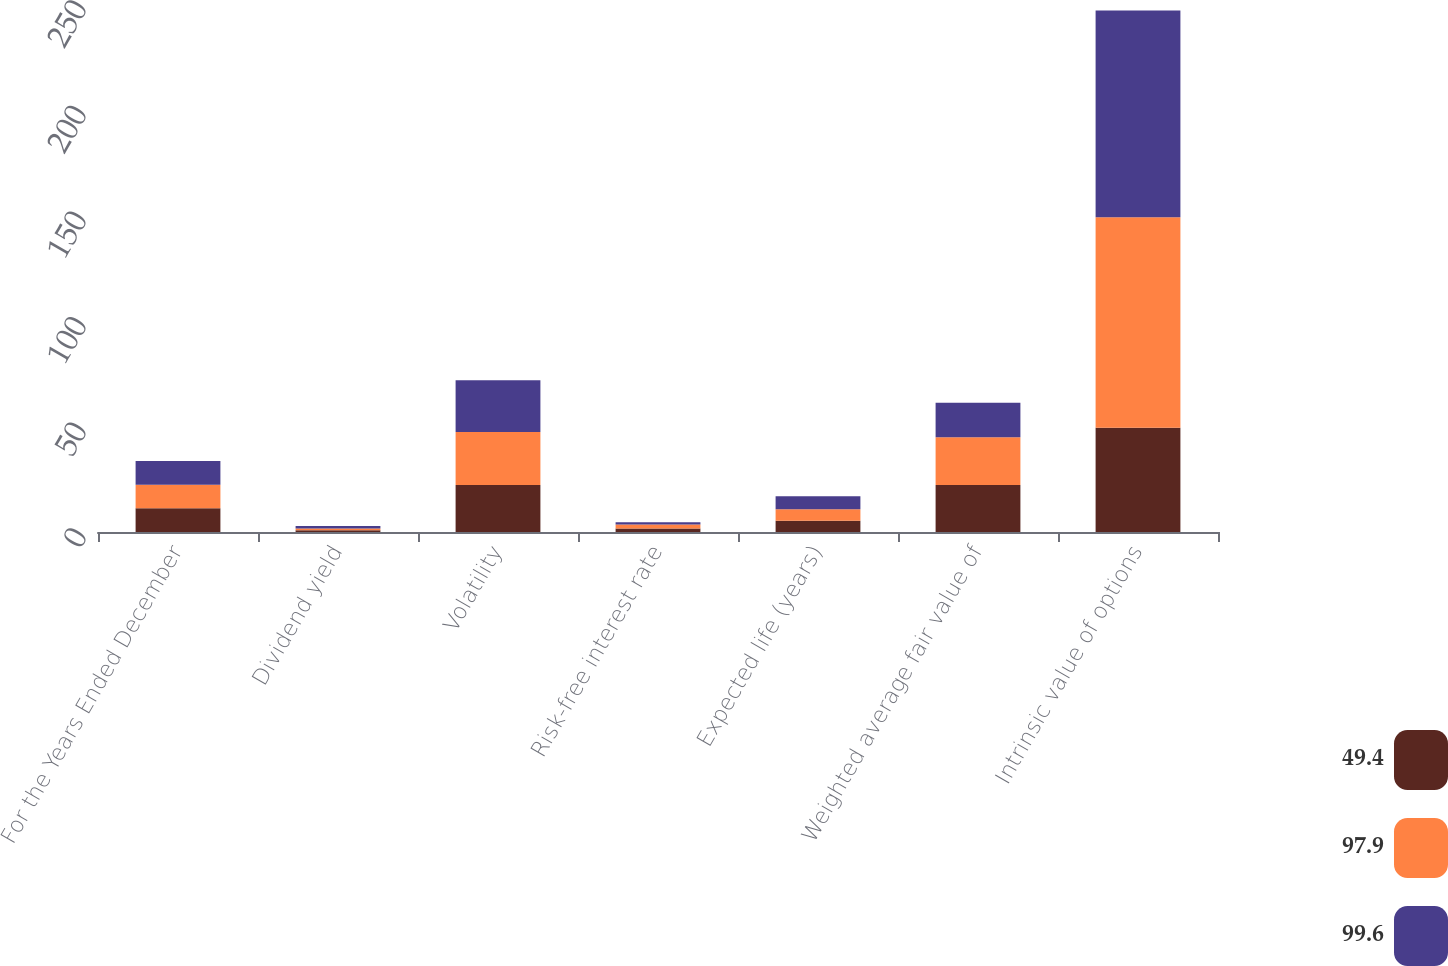Convert chart to OTSL. <chart><loc_0><loc_0><loc_500><loc_500><stacked_bar_chart><ecel><fcel>For the Years Ended December<fcel>Dividend yield<fcel>Volatility<fcel>Risk-free interest rate<fcel>Expected life (years)<fcel>Weighted average fair value of<fcel>Intrinsic value of options<nl><fcel>49.4<fcel>11.215<fcel>0.8<fcel>22.2<fcel>1.7<fcel>5.3<fcel>22.3<fcel>49.4<nl><fcel>97.9<fcel>11.215<fcel>0.9<fcel>25.2<fcel>1.8<fcel>5.5<fcel>22.59<fcel>99.6<nl><fcel>99.6<fcel>11.215<fcel>1.1<fcel>24.5<fcel>1.1<fcel>6.1<fcel>16.33<fcel>97.9<nl></chart> 